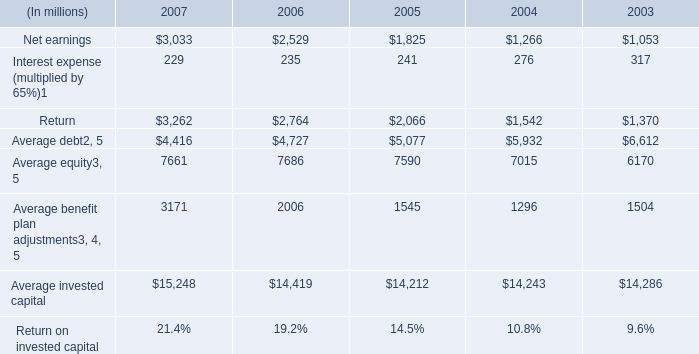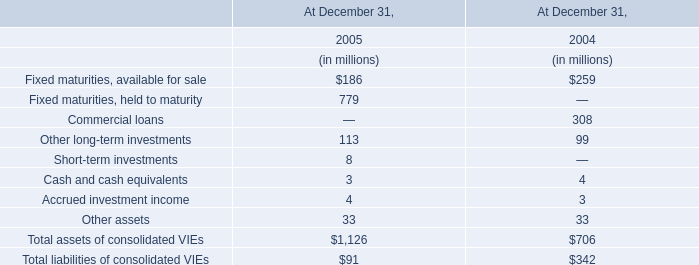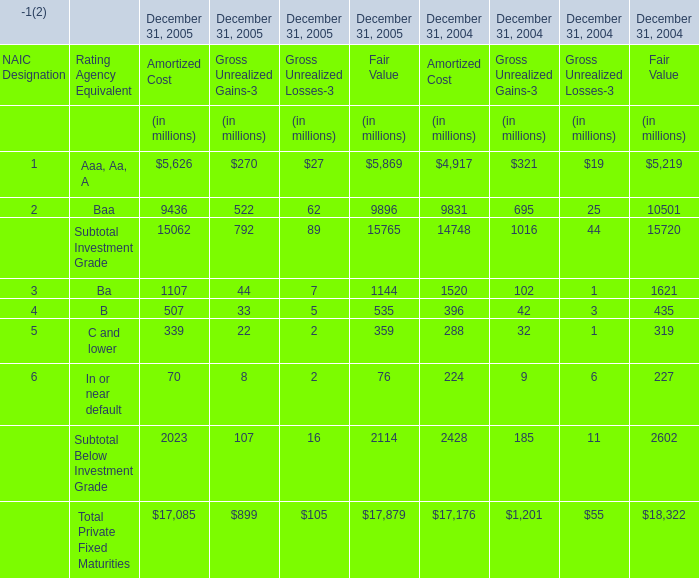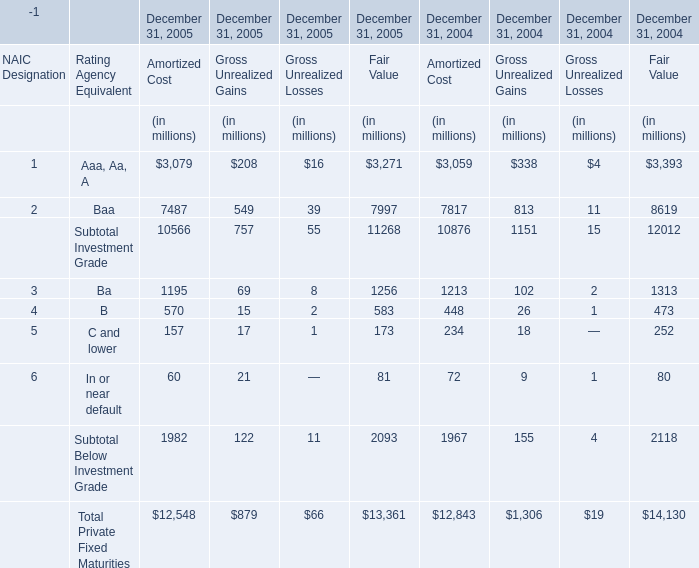What is the growing rate of B for Gross Unrealized Gains-3 in the years with the least C and lower for Gross Unrealized Gains-3 ? 
Computations: ((33 - 42) / 33)
Answer: -0.27273. 